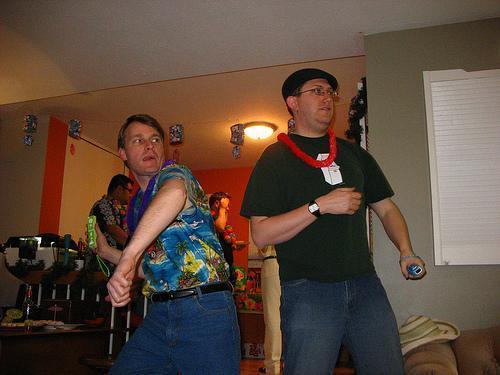How many people are reading book?
Give a very brief answer. 0. 